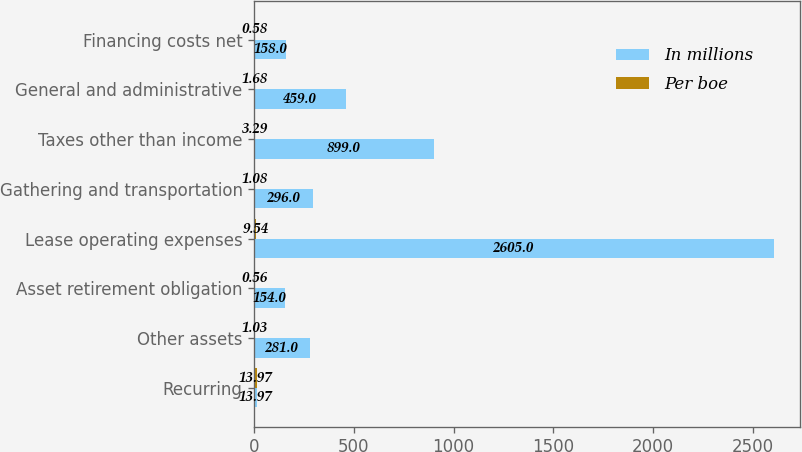Convert chart. <chart><loc_0><loc_0><loc_500><loc_500><stacked_bar_chart><ecel><fcel>Recurring<fcel>Other assets<fcel>Asset retirement obligation<fcel>Lease operating expenses<fcel>Gathering and transportation<fcel>Taxes other than income<fcel>General and administrative<fcel>Financing costs net<nl><fcel>In millions<fcel>13.97<fcel>281<fcel>154<fcel>2605<fcel>296<fcel>899<fcel>459<fcel>158<nl><fcel>Per boe<fcel>13.97<fcel>1.03<fcel>0.56<fcel>9.54<fcel>1.08<fcel>3.29<fcel>1.68<fcel>0.58<nl></chart> 